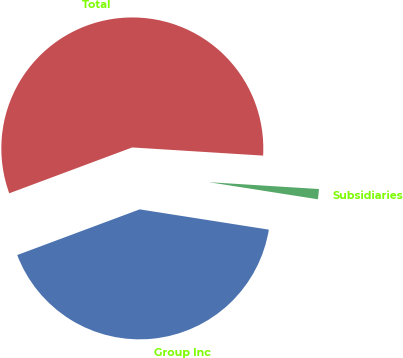Convert chart to OTSL. <chart><loc_0><loc_0><loc_500><loc_500><pie_chart><fcel>Group Inc<fcel>Subsidiaries<fcel>Total<nl><fcel>41.84%<fcel>1.49%<fcel>56.67%<nl></chart> 